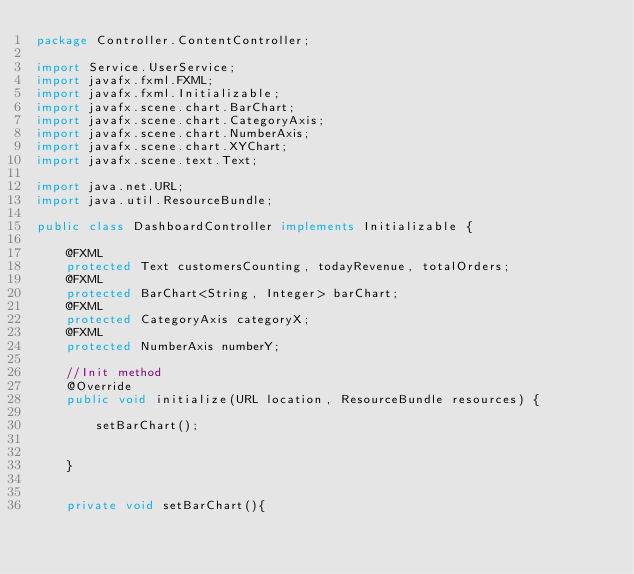<code> <loc_0><loc_0><loc_500><loc_500><_Java_>package Controller.ContentController;

import Service.UserService;
import javafx.fxml.FXML;
import javafx.fxml.Initializable;
import javafx.scene.chart.BarChart;
import javafx.scene.chart.CategoryAxis;
import javafx.scene.chart.NumberAxis;
import javafx.scene.chart.XYChart;
import javafx.scene.text.Text;

import java.net.URL;
import java.util.ResourceBundle;

public class DashboardController implements Initializable {

    @FXML
    protected Text customersCounting, todayRevenue, totalOrders;
    @FXML
    protected BarChart<String, Integer> barChart;
    @FXML
    protected CategoryAxis categoryX;
    @FXML
    protected NumberAxis numberY;

    //Init method
    @Override
    public void initialize(URL location, ResourceBundle resources) {

        setBarChart();


    }


    private void setBarChart(){
</code> 